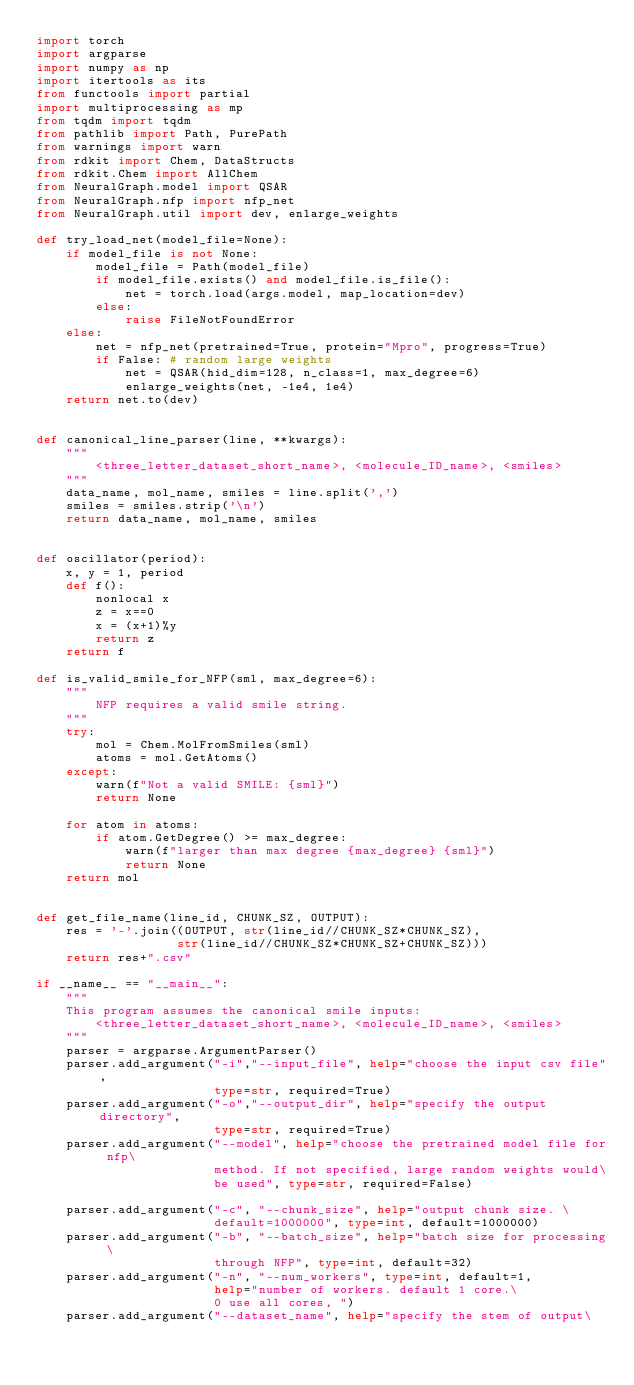Convert code to text. <code><loc_0><loc_0><loc_500><loc_500><_Python_>import torch
import argparse
import numpy as np
import itertools as its
from functools import partial
import multiprocessing as mp
from tqdm import tqdm
from pathlib import Path, PurePath
from warnings import warn
from rdkit import Chem, DataStructs
from rdkit.Chem import AllChem
from NeuralGraph.model import QSAR
from NeuralGraph.nfp import nfp_net
from NeuralGraph.util import dev, enlarge_weights

def try_load_net(model_file=None):
    if model_file is not None:
        model_file = Path(model_file)
        if model_file.exists() and model_file.is_file():
            net = torch.load(args.model, map_location=dev)
        else:
            raise FileNotFoundError
    else: 
        net = nfp_net(pretrained=True, protein="Mpro", progress=True)
        if False: # random large weights
            net = QSAR(hid_dim=128, n_class=1, max_degree=6)
            enlarge_weights(net, -1e4, 1e4)
    return net.to(dev)


def canonical_line_parser(line, **kwargs):
    """
        <three_letter_dataset_short_name>, <molecule_ID_name>, <smiles>
    """
    data_name, mol_name, smiles = line.split(',')
    smiles = smiles.strip('\n')
    return data_name, mol_name, smiles


def oscillator(period):
    x, y = 1, period
    def f():
        nonlocal x
        z = x==0
        x = (x+1)%y
        return z
    return f

def is_valid_smile_for_NFP(sml, max_degree=6):
    """
        NFP requires a valid smile string. 
    """
    try:
        mol = Chem.MolFromSmiles(sml)
        atoms = mol.GetAtoms()
    except:
        warn(f"Not a valid SMILE: {sml}")
        return None

    for atom in atoms:
        if atom.GetDegree() >= max_degree:
            warn(f"larger than max degree {max_degree} {sml}")
            return None
    return mol


def get_file_name(line_id, CHUNK_SZ, OUTPUT):
    res = '-'.join((OUTPUT, str(line_id//CHUNK_SZ*CHUNK_SZ),
                   str(line_id//CHUNK_SZ*CHUNK_SZ+CHUNK_SZ)))
    return res+".csv"

if __name__ == "__main__":
    """
    This program assumes the canonical smile inputs:
        <three_letter_dataset_short_name>, <molecule_ID_name>, <smiles>
    """
    parser = argparse.ArgumentParser()
    parser.add_argument("-i","--input_file", help="choose the input csv file",
                        type=str, required=True)
    parser.add_argument("-o","--output_dir", help="specify the output directory",
                        type=str, required=True)
    parser.add_argument("--model", help="choose the pretrained model file for nfp\
                        method. If not specified, large random weights would\
                        be used", type=str, required=False)

    parser.add_argument("-c", "--chunk_size", help="output chunk size. \
                        default=1000000", type=int, default=1000000)
    parser.add_argument("-b", "--batch_size", help="batch size for processing \
                        through NFP", type=int, default=32)
    parser.add_argument("-n", "--num_workers", type=int, default=1,
                        help="number of workers. default 1 core.\
                        0 use all cores, ")
    parser.add_argument("--dataset_name", help="specify the stem of output\</code> 